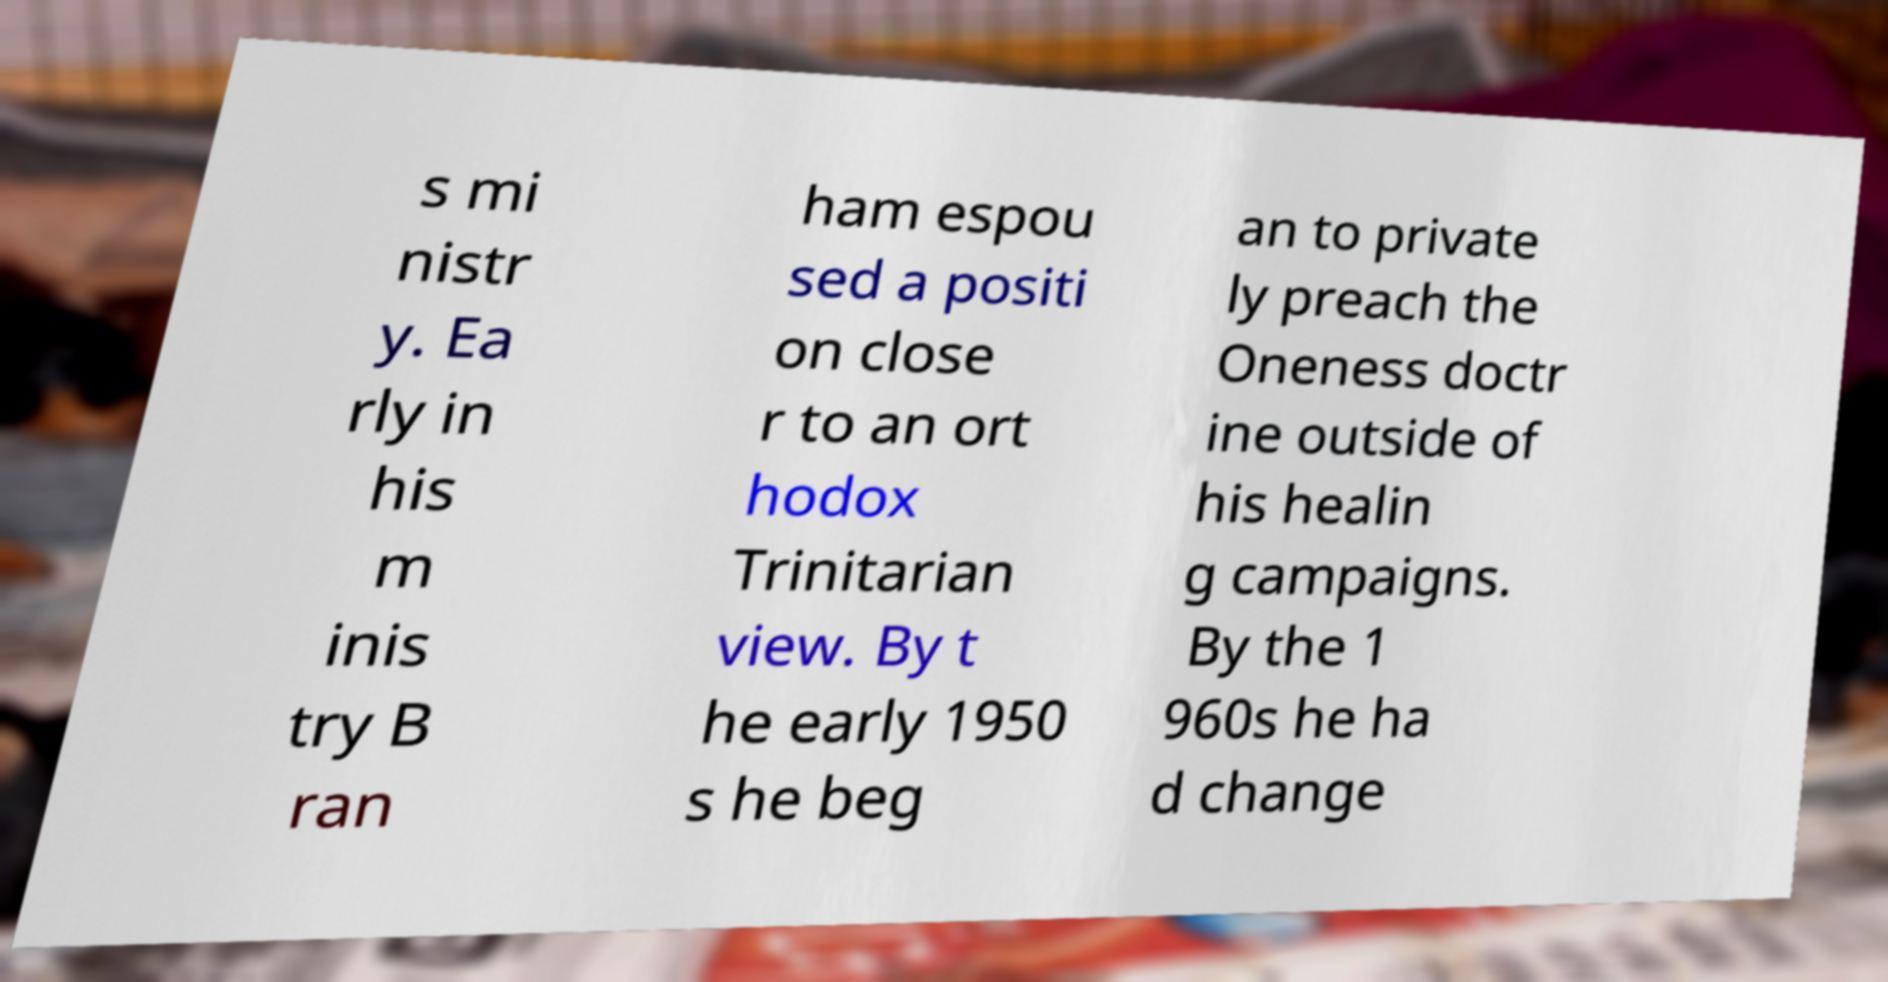Can you accurately transcribe the text from the provided image for me? s mi nistr y. Ea rly in his m inis try B ran ham espou sed a positi on close r to an ort hodox Trinitarian view. By t he early 1950 s he beg an to private ly preach the Oneness doctr ine outside of his healin g campaigns. By the 1 960s he ha d change 